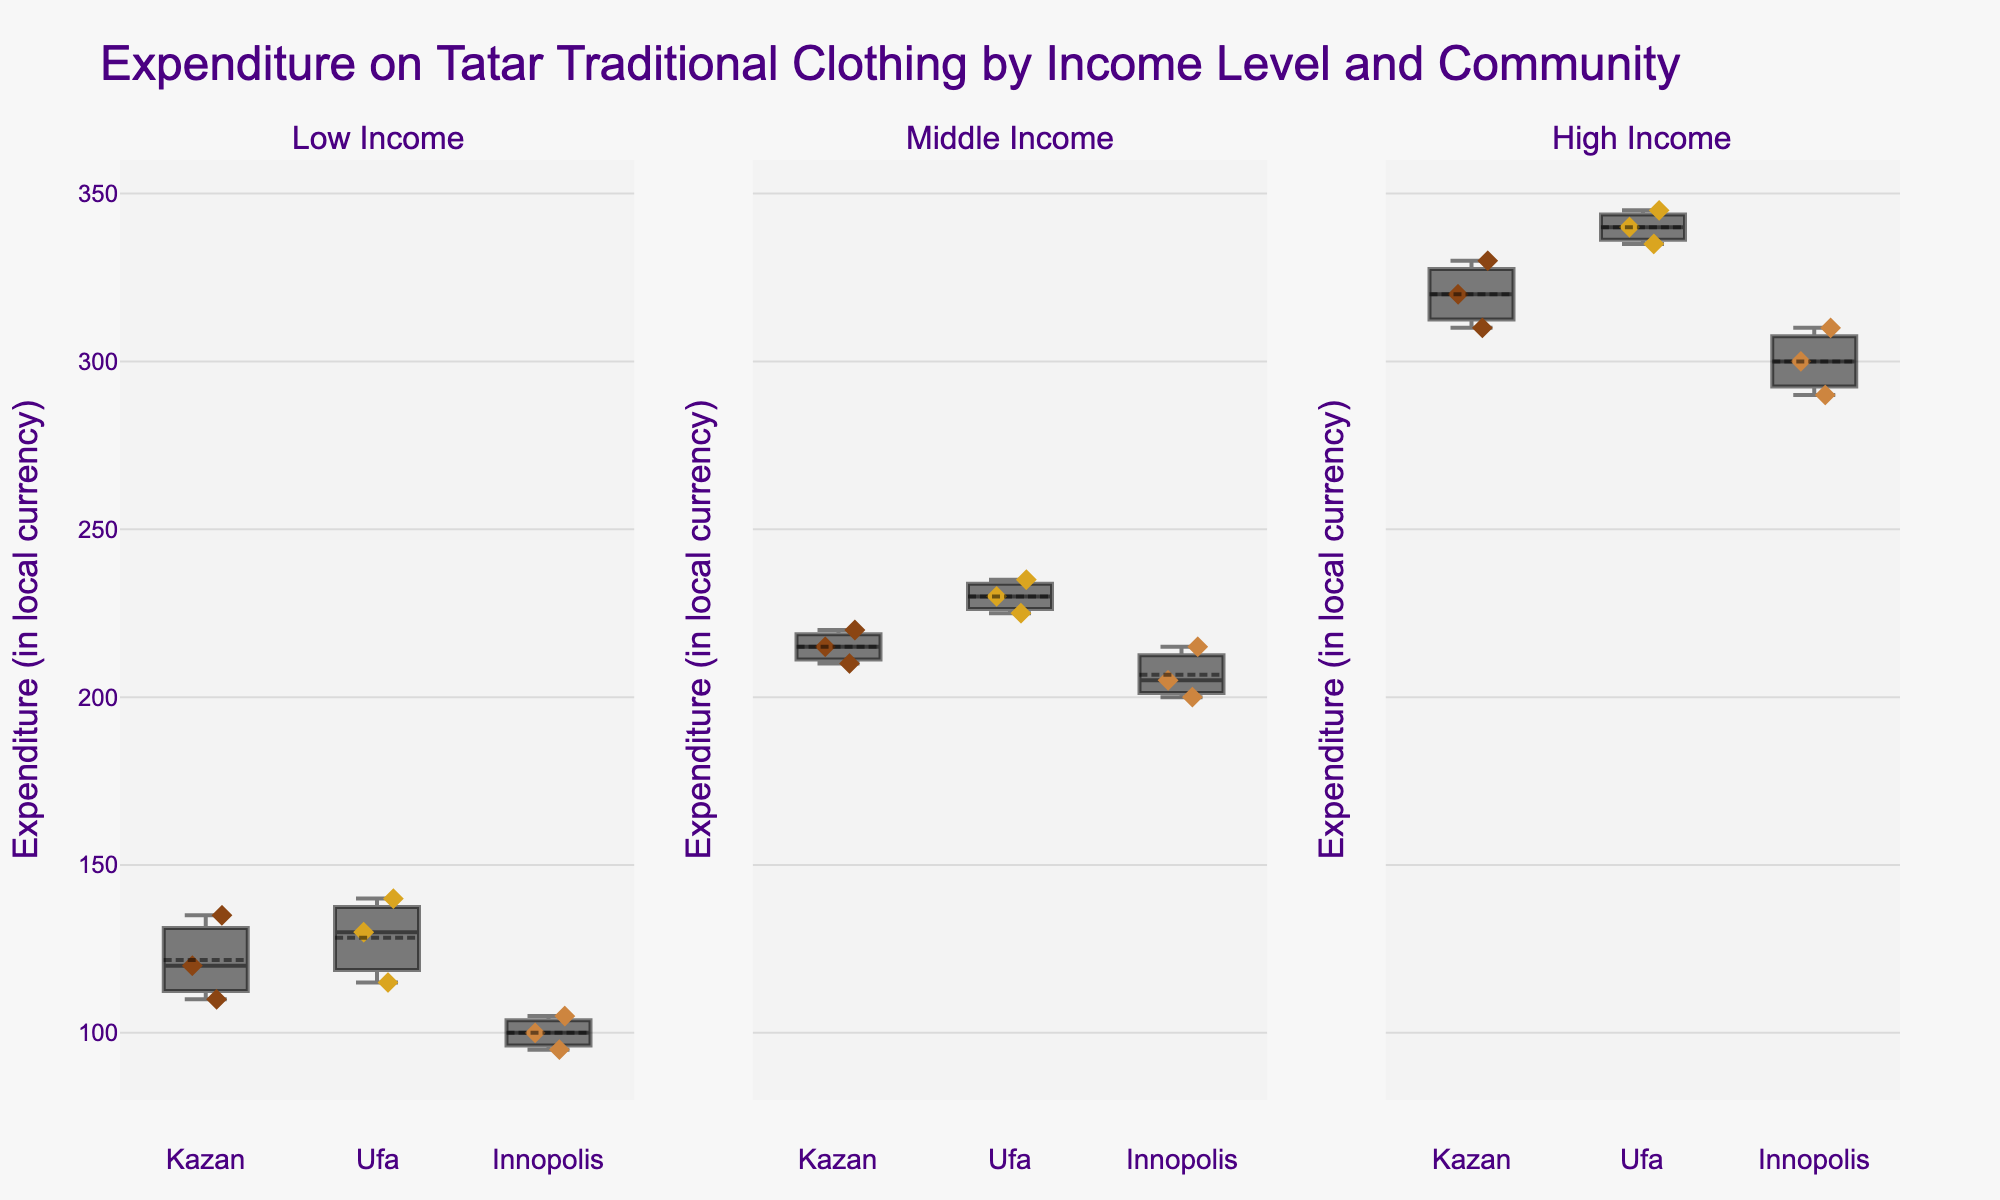What's the title of the figure? The title is displayed at the top of the figure and provides the main context and purpose of the chart. It typically summarizes what the data represents.
Answer: "Expenditure on Tatar Traditional Clothing by Income Level and Community" Which communities are compared in the figure? The communities compared are indicated by the names associated with the box plots on the x-axis of the figure: Kazan, Ufa, and Innopolis.
Answer: Kazan, Ufa, Innopolis Which income level shows the highest median expenditure on traditional clothing in Kazan? By looking at the middle line inside the box plot for Kazan across income levels, the High Income level shows the highest median expenditure since the line is positioned higher on the y-axis than the others.
Answer: High Income What is the range of expenditures for High Income families in Ufa? The range is the difference between the maximum and minimum values represented by the top and bottom whiskers of the box plot for High Income families in Ufa. The maximum is around 345 and the minimum is around 335, making the range 345 - 335.
Answer: 10 Which community has the widest range of expenditure within the Middle Income group? The range for each community in the Middle Income group can be determined by examining the lengths of the whiskers. Ufa shows the widest range since its whiskers extend further compared to Kazan and Innopolis.
Answer: Ufa Is there a significant difference in expenditure on traditional clothing between Low Income and High Income families in Innopolis? By comparing the Low Income and High Income box plots for Innopolis, we can see a clear difference in their medians and ranges. High Income families have higher expenditures with a median around 300 compared to Low Income families with a median around 100.
Answer: Yes What is the median expenditure on traditional clothing for Middle Income families in each community? The median can be identified by the line inside the box. For Middle Income families: Kazan's median is around 215, Ufa's median is around 230, and Innopolis's median is around 205.
Answer: Kazan: 215, Ufa: 230, Innopolis: 205 Which group in Kazan exhibits the least variability in expenditure? Variability in a box plot is indicated by the Interquartile Range (IQR). For Kazan, Low Income families show the least variability, as their box plot is the most compact.
Answer: Low Income Compare the mean expenditure between Low Income and Middle Income families in Ufa. The mean value is indicated by a marker or dot within the box plot. For Low Income families in Ufa, the mean is around 128, and for Middle Income families, the mean is around 230. The difference in their means is 230 - 128.
Answer: 102 